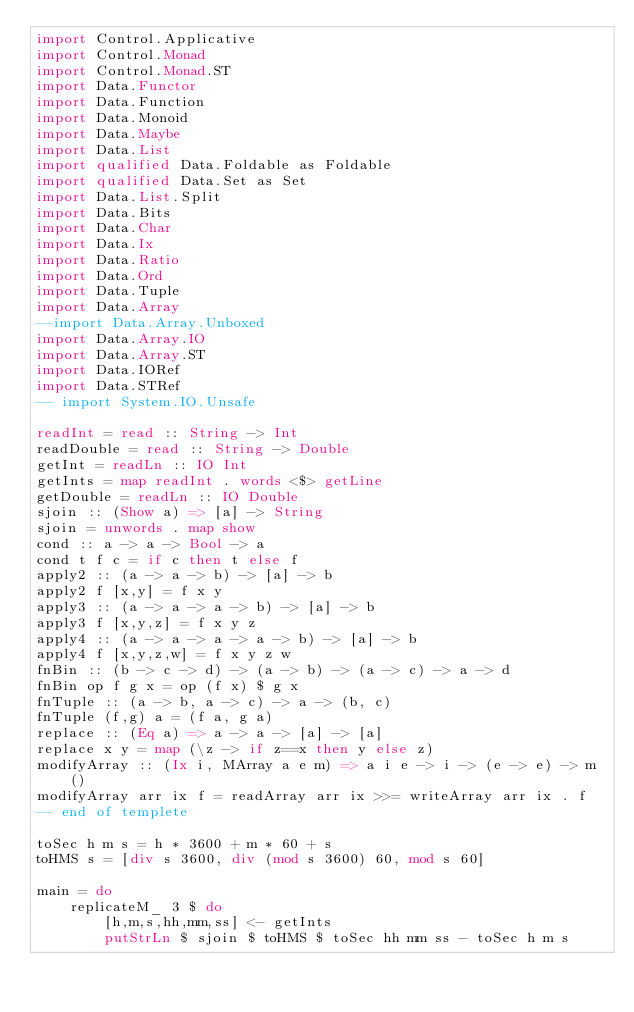<code> <loc_0><loc_0><loc_500><loc_500><_Haskell_>import Control.Applicative
import Control.Monad
import Control.Monad.ST
import Data.Functor
import Data.Function
import Data.Monoid
import Data.Maybe
import Data.List
import qualified Data.Foldable as Foldable
import qualified Data.Set as Set
import Data.List.Split
import Data.Bits
import Data.Char
import Data.Ix
import Data.Ratio
import Data.Ord
import Data.Tuple
import Data.Array
--import Data.Array.Unboxed
import Data.Array.IO
import Data.Array.ST
import Data.IORef
import Data.STRef
-- import System.IO.Unsafe
 
readInt = read :: String -> Int
readDouble = read :: String -> Double
getInt = readLn :: IO Int
getInts = map readInt . words <$> getLine
getDouble = readLn :: IO Double
sjoin :: (Show a) => [a] -> String
sjoin = unwords . map show
cond :: a -> a -> Bool -> a
cond t f c = if c then t else f
apply2 :: (a -> a -> b) -> [a] -> b
apply2 f [x,y] = f x y
apply3 :: (a -> a -> a -> b) -> [a] -> b
apply3 f [x,y,z] = f x y z
apply4 :: (a -> a -> a -> a -> b) -> [a] -> b
apply4 f [x,y,z,w] = f x y z w
fnBin :: (b -> c -> d) -> (a -> b) -> (a -> c) -> a -> d
fnBin op f g x = op (f x) $ g x
fnTuple :: (a -> b, a -> c) -> a -> (b, c)
fnTuple (f,g) a = (f a, g a)
replace :: (Eq a) => a -> a -> [a] -> [a]
replace x y = map (\z -> if z==x then y else z)
modifyArray :: (Ix i, MArray a e m) => a i e -> i -> (e -> e) -> m ()
modifyArray arr ix f = readArray arr ix >>= writeArray arr ix . f
-- end of templete

toSec h m s = h * 3600 + m * 60 + s
toHMS s = [div s 3600, div (mod s 3600) 60, mod s 60]

main = do
    replicateM_ 3 $ do
        [h,m,s,hh,mm,ss] <- getInts
        putStrLn $ sjoin $ toHMS $ toSec hh mm ss - toSec h m s</code> 